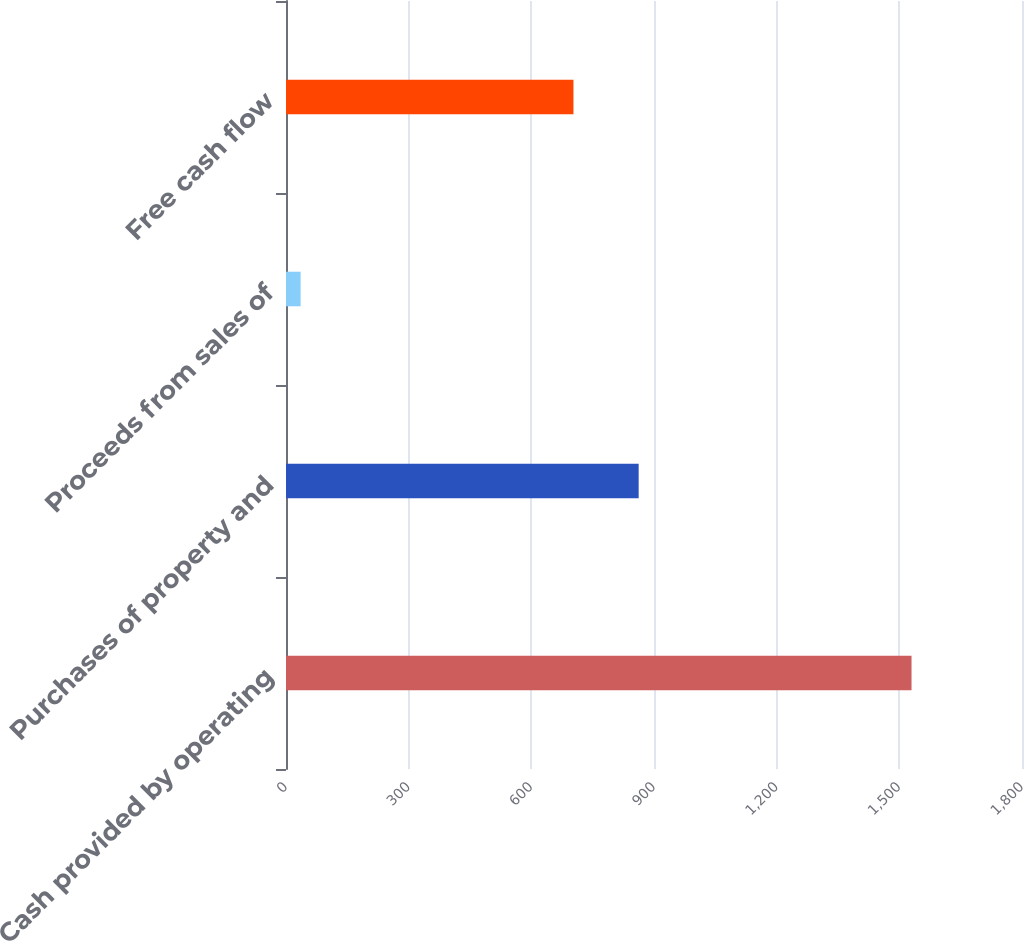Convert chart. <chart><loc_0><loc_0><loc_500><loc_500><bar_chart><fcel>Cash provided by operating<fcel>Purchases of property and<fcel>Proceeds from sales of<fcel>Free cash flow<nl><fcel>1529.8<fcel>862.5<fcel>35.7<fcel>703<nl></chart> 